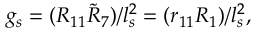Convert formula to latex. <formula><loc_0><loc_0><loc_500><loc_500>g _ { s } = ( R _ { 1 1 } \tilde { R } _ { 7 } ) / l _ { s } ^ { 2 } = ( r _ { 1 1 } R _ { 1 } ) / l _ { s } ^ { 2 } ,</formula> 